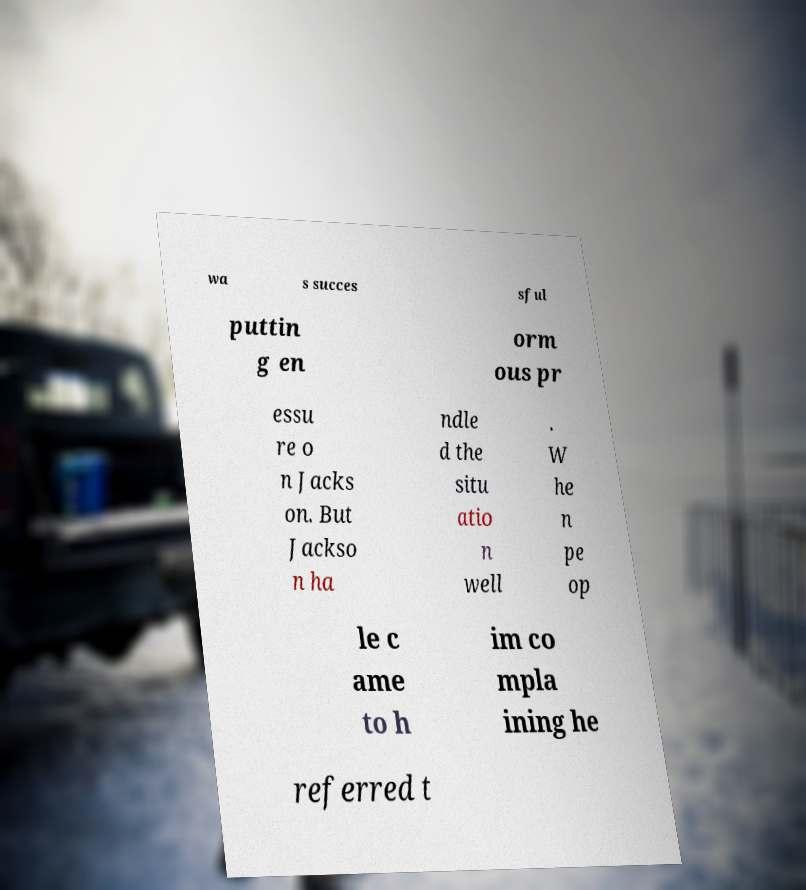There's text embedded in this image that I need extracted. Can you transcribe it verbatim? wa s succes sful puttin g en orm ous pr essu re o n Jacks on. But Jackso n ha ndle d the situ atio n well . W he n pe op le c ame to h im co mpla ining he referred t 